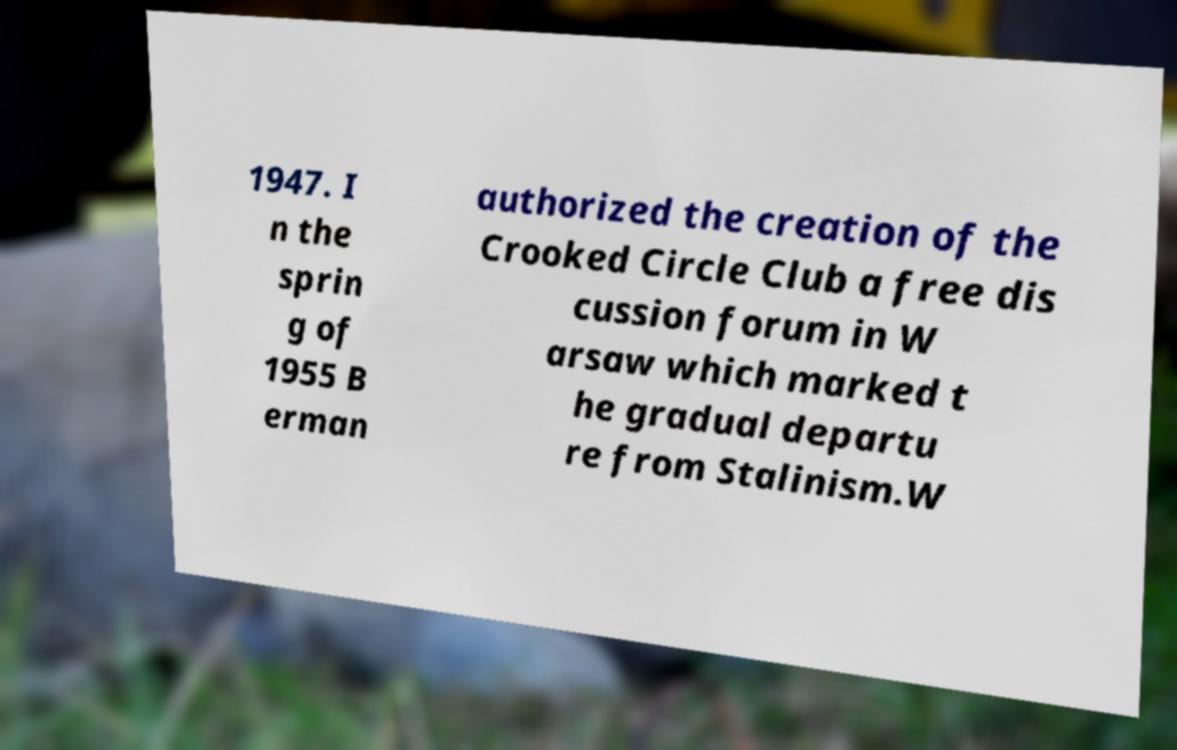Can you read and provide the text displayed in the image?This photo seems to have some interesting text. Can you extract and type it out for me? 1947. I n the sprin g of 1955 B erman authorized the creation of the Crooked Circle Club a free dis cussion forum in W arsaw which marked t he gradual departu re from Stalinism.W 